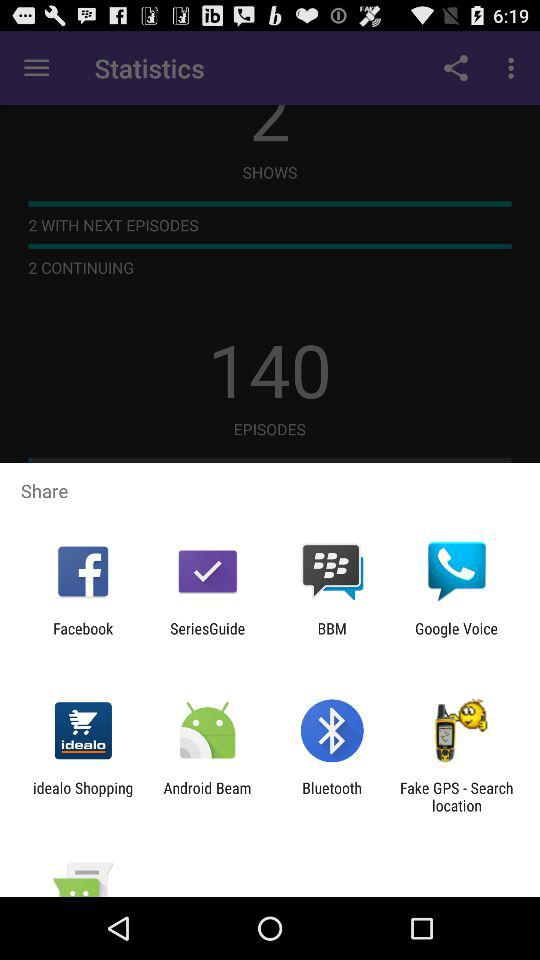How many more episodes do I have than continuing shows?
Answer the question using a single word or phrase. 140 